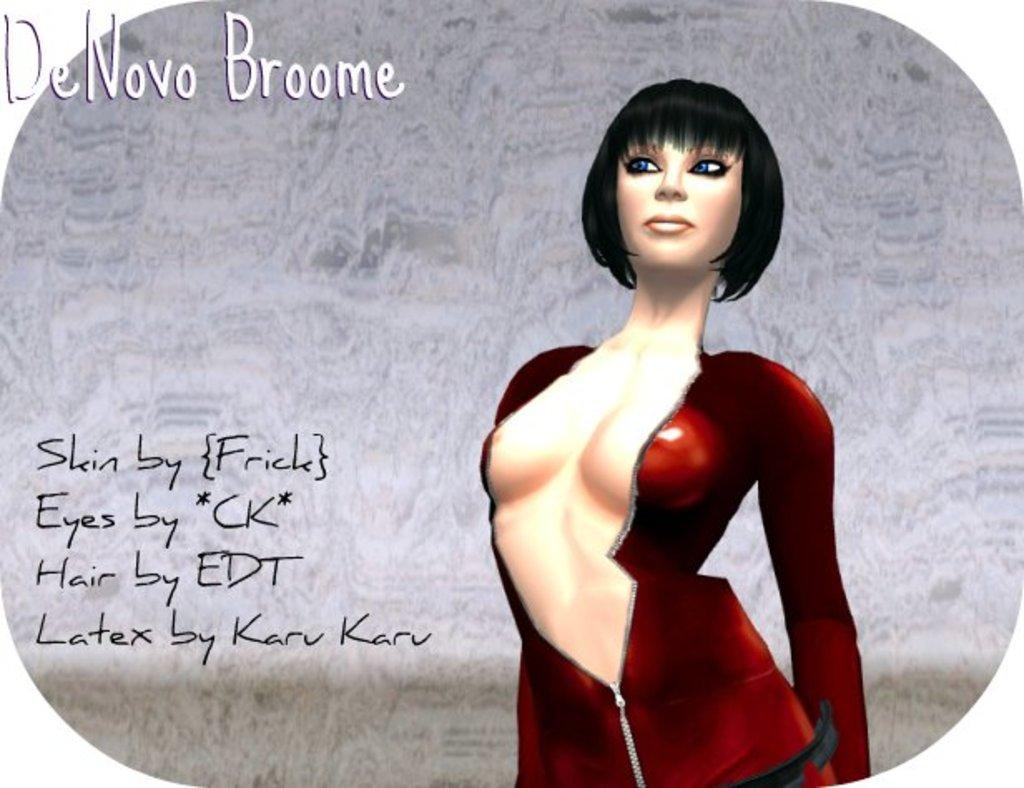Who is present in the image? There is a woman in the image. What is the woman wearing? The woman is wearing a red dress. What can be seen beside the woman? There is something written beside the woman. What type of cloth is being used to cover the nail in the image? There is no cloth or nail present in the image. What class is the woman attending in the image? The image does not provide any information about a class or the woman's attendance. 